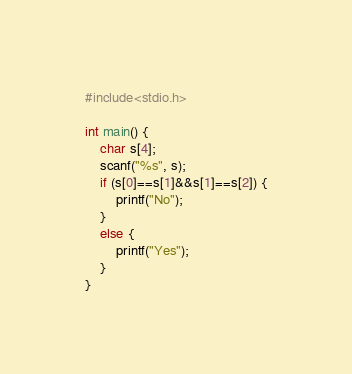Convert code to text. <code><loc_0><loc_0><loc_500><loc_500><_C_>#include<stdio.h>

int main() {
	char s[4];
	scanf("%s", s);
	if (s[0]==s[1]&&s[1]==s[2]) {
		printf("No");
	}
	else {
		printf("Yes");
	}
}</code> 